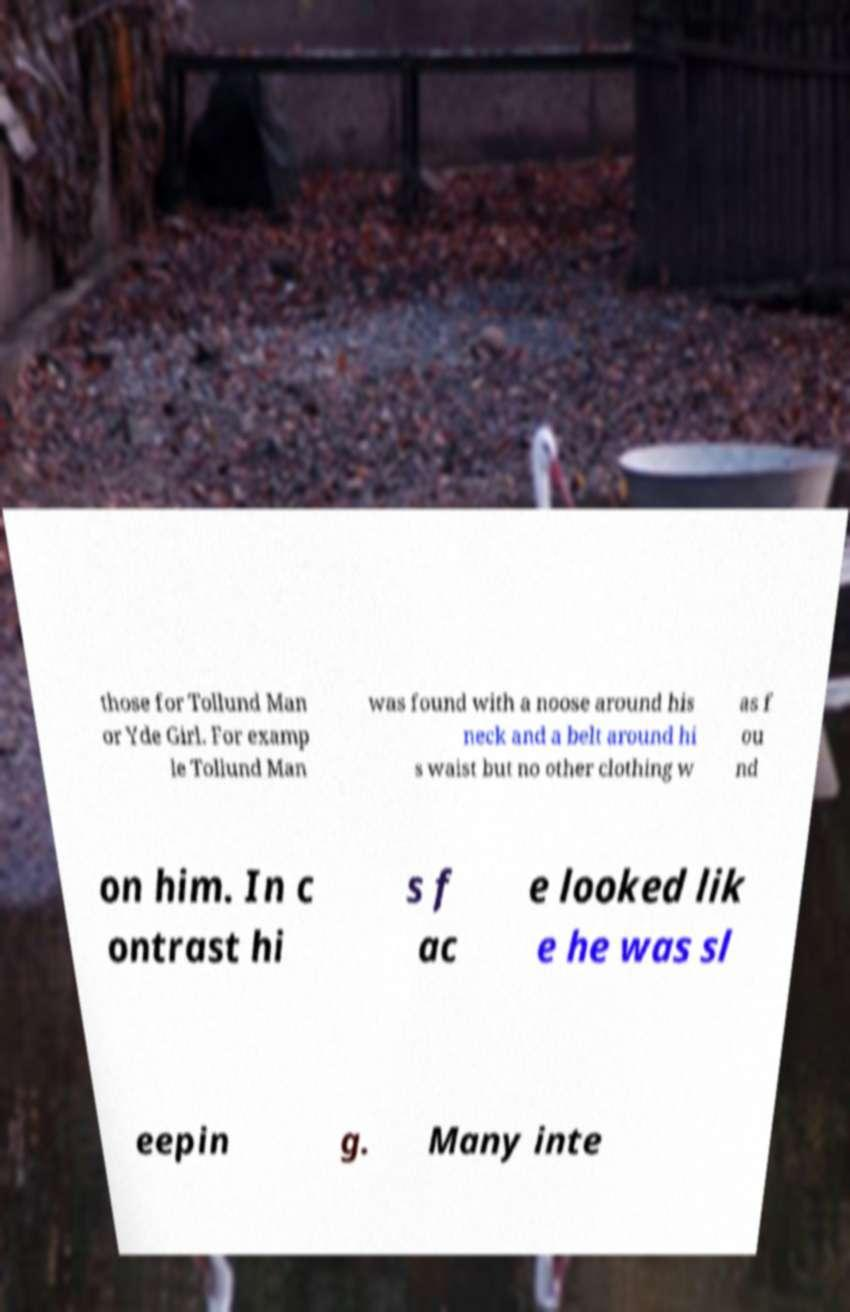Please identify and transcribe the text found in this image. those for Tollund Man or Yde Girl. For examp le Tollund Man was found with a noose around his neck and a belt around hi s waist but no other clothing w as f ou nd on him. In c ontrast hi s f ac e looked lik e he was sl eepin g. Many inte 